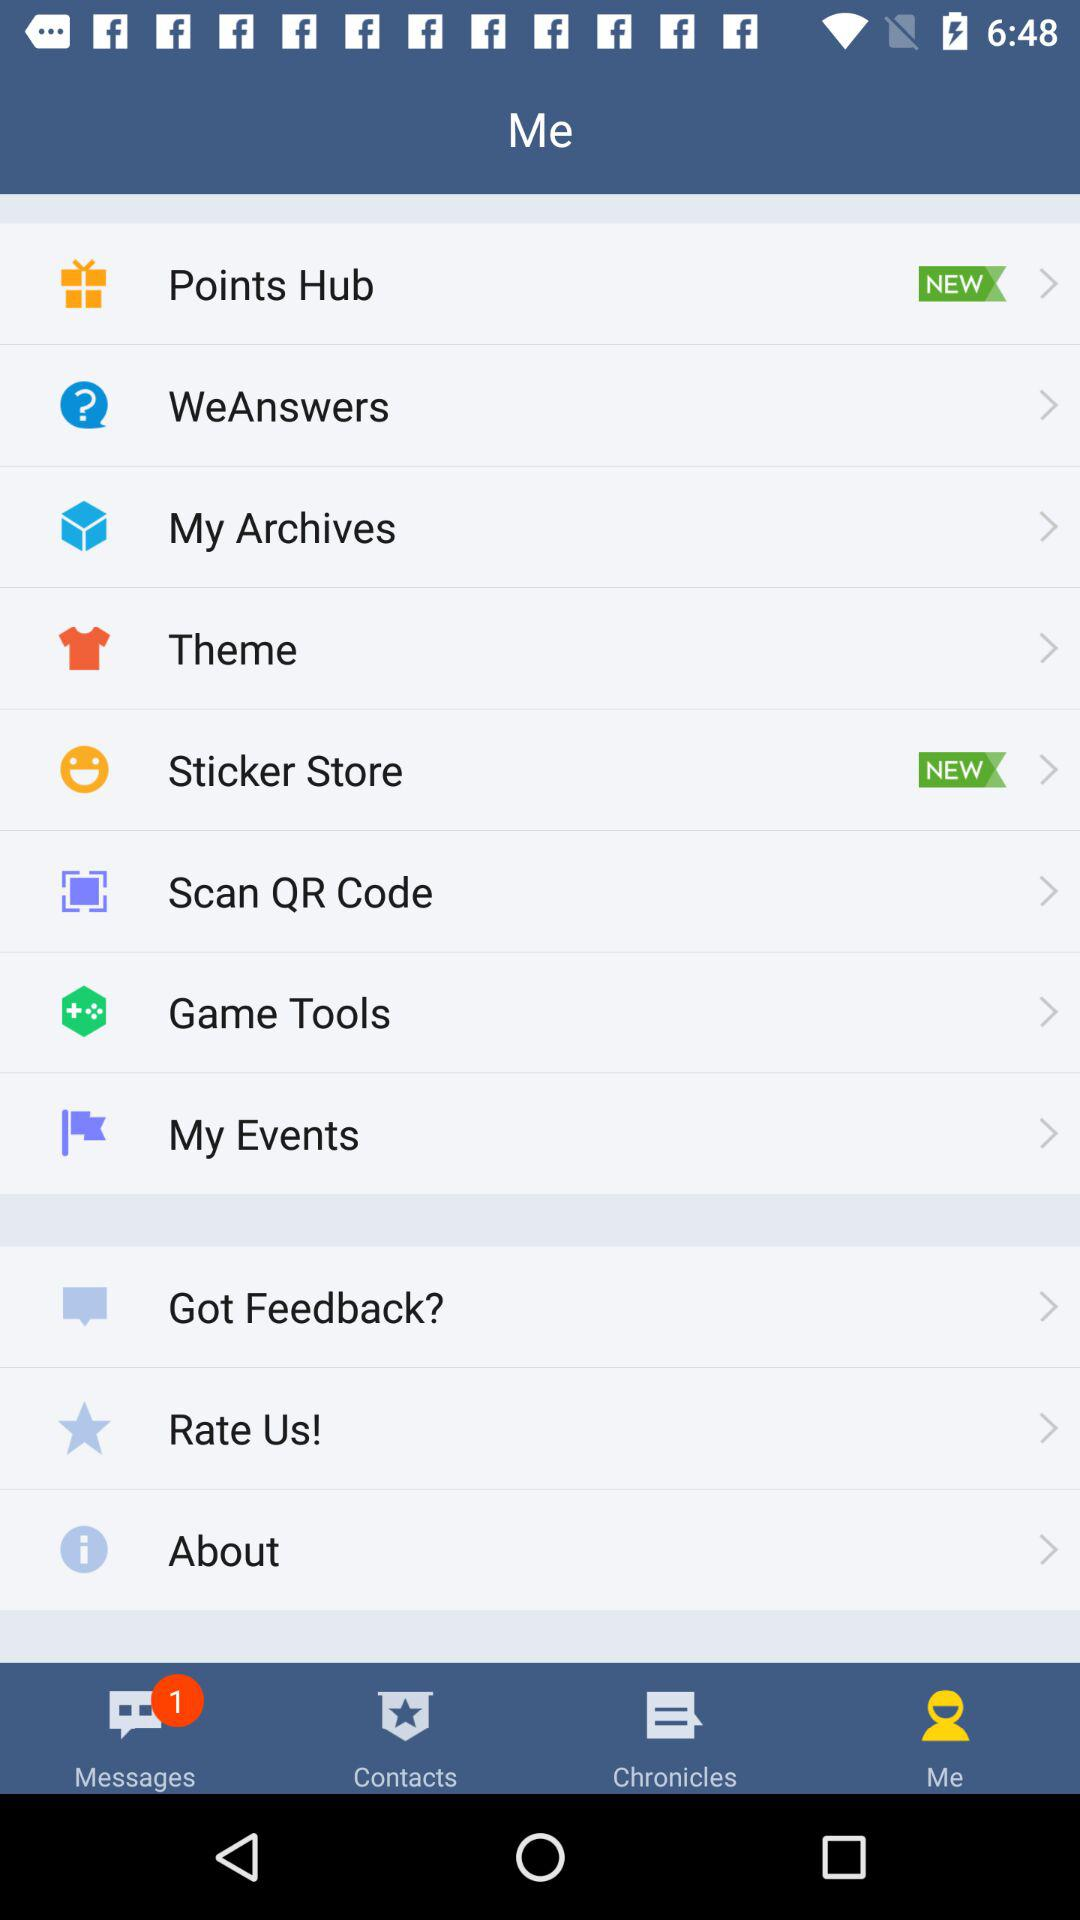How many unread messages are there? There is 1 unread message. 